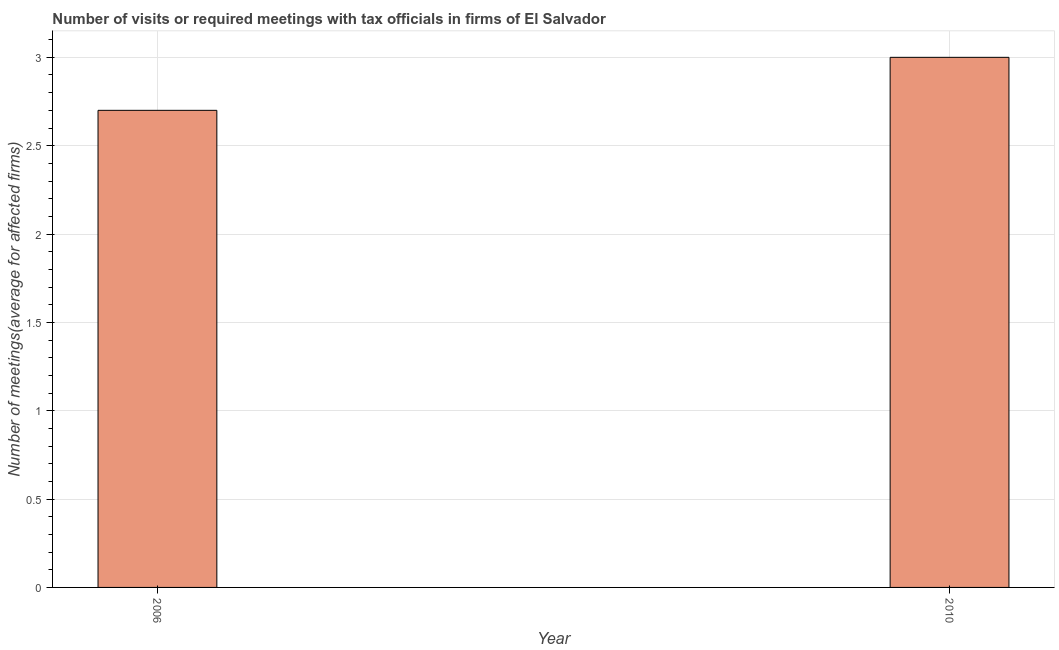What is the title of the graph?
Offer a very short reply. Number of visits or required meetings with tax officials in firms of El Salvador. What is the label or title of the X-axis?
Your answer should be compact. Year. What is the label or title of the Y-axis?
Provide a succinct answer. Number of meetings(average for affected firms). What is the number of required meetings with tax officials in 2006?
Keep it short and to the point. 2.7. Across all years, what is the maximum number of required meetings with tax officials?
Keep it short and to the point. 3. In which year was the number of required meetings with tax officials maximum?
Give a very brief answer. 2010. In which year was the number of required meetings with tax officials minimum?
Your answer should be compact. 2006. What is the sum of the number of required meetings with tax officials?
Provide a short and direct response. 5.7. What is the difference between the number of required meetings with tax officials in 2006 and 2010?
Ensure brevity in your answer.  -0.3. What is the average number of required meetings with tax officials per year?
Provide a short and direct response. 2.85. What is the median number of required meetings with tax officials?
Your response must be concise. 2.85. In how many years, is the number of required meetings with tax officials greater than 3 ?
Ensure brevity in your answer.  0. Do a majority of the years between 2006 and 2010 (inclusive) have number of required meetings with tax officials greater than 1.5 ?
Provide a succinct answer. Yes. Is the number of required meetings with tax officials in 2006 less than that in 2010?
Ensure brevity in your answer.  Yes. How many years are there in the graph?
Provide a succinct answer. 2. What is the Number of meetings(average for affected firms) of 2010?
Your response must be concise. 3. 